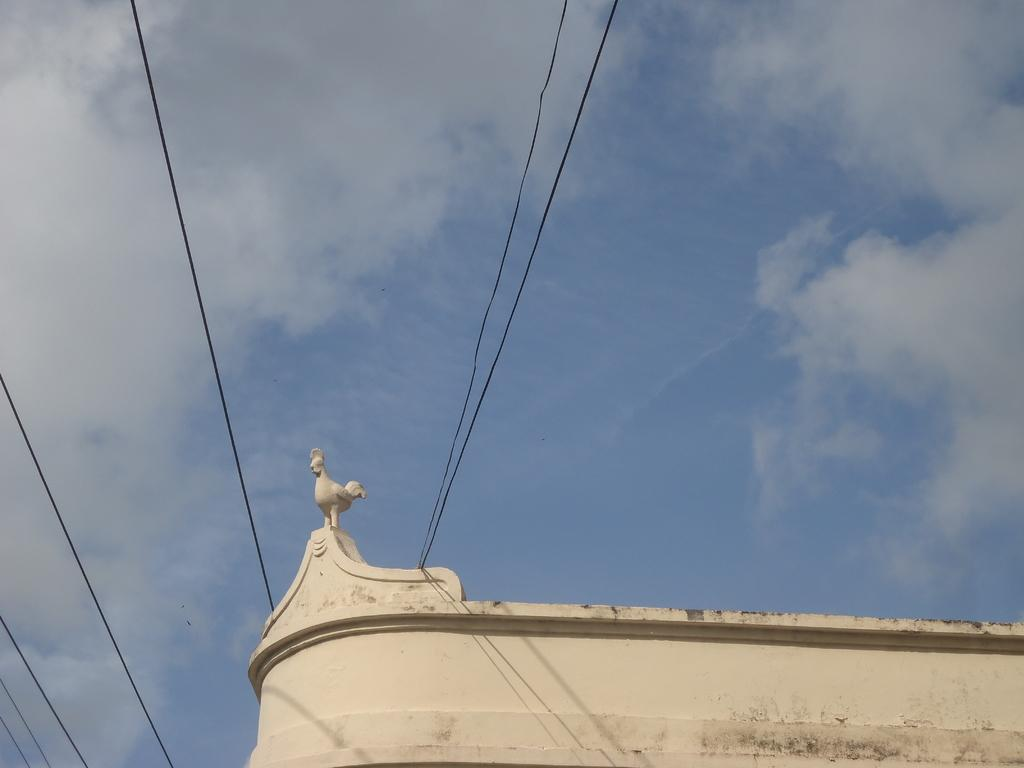What is the color and condition of the sky in the image? The sky is clear and blue with clouds in the image. What type of wires can be seen in the image? Black transmission wires are visible in the image. What part of a structure is visible in the image? There is a partial view of a wall, and it appears to be the top of a building. What is the opinion of the match on the building's design in the image? There is no match present in the image, and therefore no opinion can be attributed to it. 